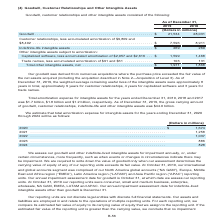According to Centurylink's financial document, How was goodwill derived? from numerous acquisitions where the purchase price exceeded the fair value of the net assets acquired (including the acquisition described in Note 2—Acquisition of Level 3). The document states: "Our goodwill was derived from numerous acquisitions where the purchase price exceeded the fair value of the net assets acquired (including the acquisi..." Also, What was the gross carrying amount of goodwill, customer relationships, indefinite-life and other intangible assets as of December 31, 2019? According to the financial document, $44.0 billion. The relevant text states: "s, indefinite-life and other intangible assets was $44.0 billion...." Also, The weighted average remaining useful lives of which items were provided? The document contains multiple relevant values: intangible assets, customer relationships, capitalized software, trade names. From the document: "(4) Goodwill, Customer Relationships and Other Intangible Assets Other intangible assets subject to amortization: Capitalized software, less accumulat..." Additionally, Which item has the longest weighted average remaining useful life? Customer relationships. The document states: "(4) Goodwill, Customer Relationships and Other Intangible Assets..." Also, can you calculate: What is the total amortization expense for intangible assets for 2017, 2018 and 2019? Based on the calculation: $1.7+$1.8+$1.2, the result is 4.7 (in billions). This is based on the information: "cember 31, 2019, 2018 and 2017 was $1.7 billion, $1.8 billion and $1.2 billion, respectively. As of December 31, 2019, the gross carrying amount of goodw 2018 and 2017 was $1.7 billion, $1.8 billion a..." The key data points involved are: 1.2, 1.7, 1.8. Also, can you calculate: What is the percentage change in total other intangible assets, net from 2018 to 2019? To answer this question, I need to perform calculations using the financial data. The calculation is: (1,971-1,868)/1,868, which equals 5.51 (percentage). This is based on the information: "Total other intangible assets, net . $ 1,971 1,868 Total other intangible assets, net . $ 1,971 1,868..." The key data points involved are: 1,868, 1,971. 